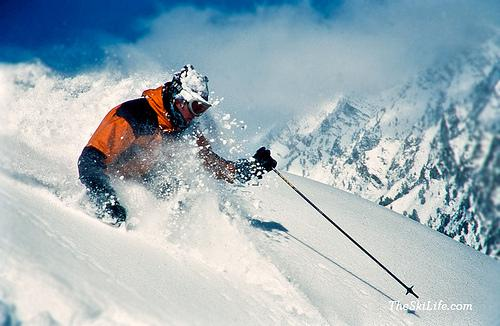Question: what is in the background?
Choices:
A. River.
B. Mountains.
C. City.
D. Ocean.
Answer with the letter. Answer: B Question: what color is the skiers jacket?
Choices:
A. Pink and red.
B. White and purple.
C. Orange and black.
D. Gray and green.
Answer with the letter. Answer: C Question: who has a helmet on?
Choices:
A. Motorcycle rider.
B. Skateboarder.
C. The skier.
D. Snowboarder.
Answer with the letter. Answer: C Question: where is this photo taken?
Choices:
A. Ocean.
B. Desert.
C. In the mountains.
D. Field.
Answer with the letter. Answer: C 